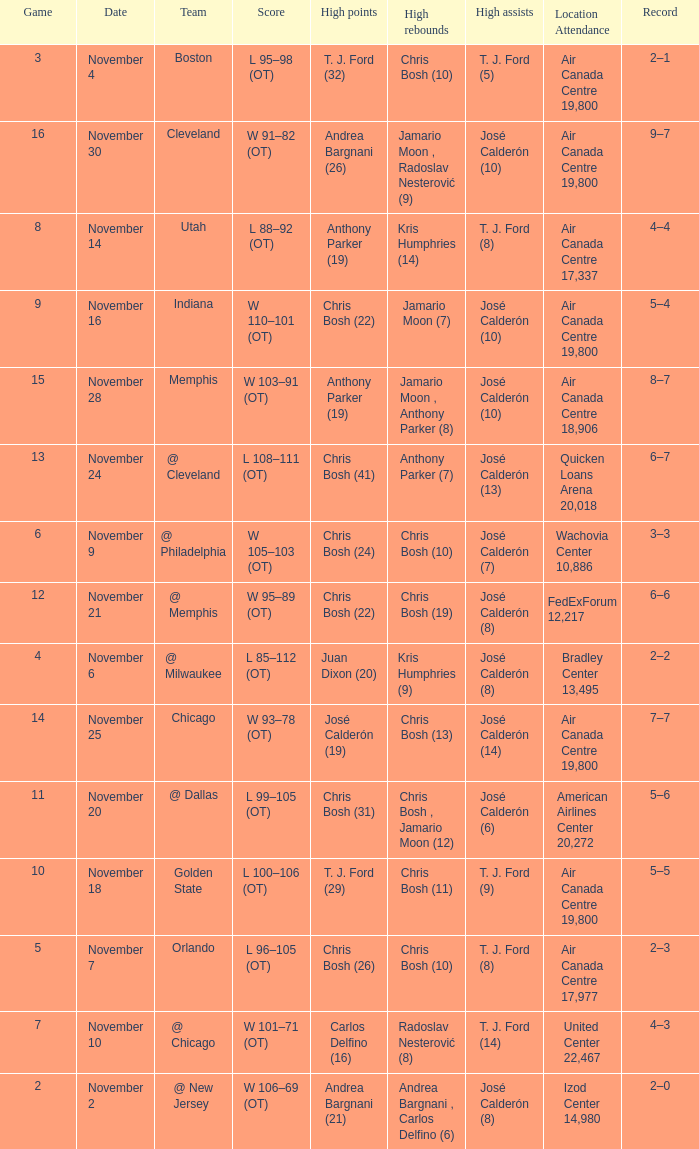Who had the high rebounds when the game number was 6? Chris Bosh (10). 